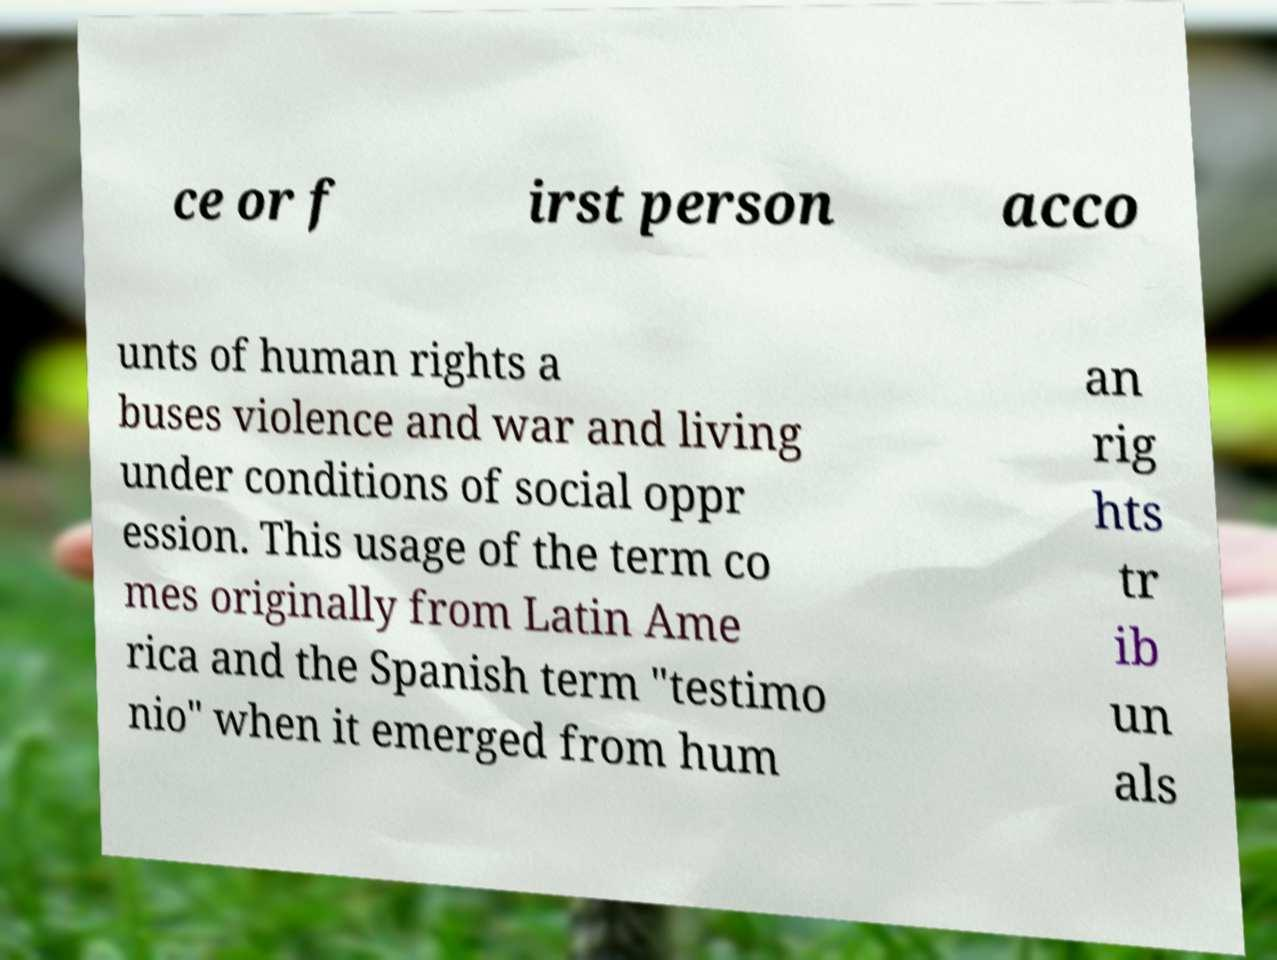Can you accurately transcribe the text from the provided image for me? ce or f irst person acco unts of human rights a buses violence and war and living under conditions of social oppr ession. This usage of the term co mes originally from Latin Ame rica and the Spanish term "testimo nio" when it emerged from hum an rig hts tr ib un als 